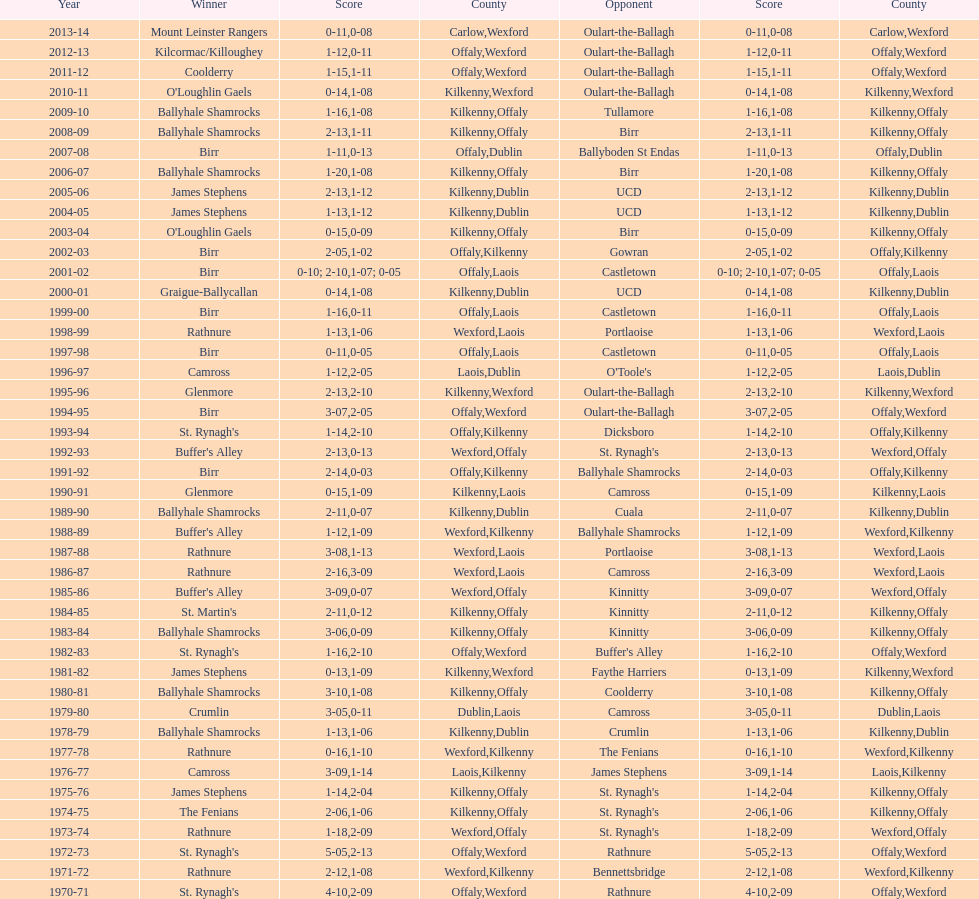Which country had the most wins? Kilkenny. 